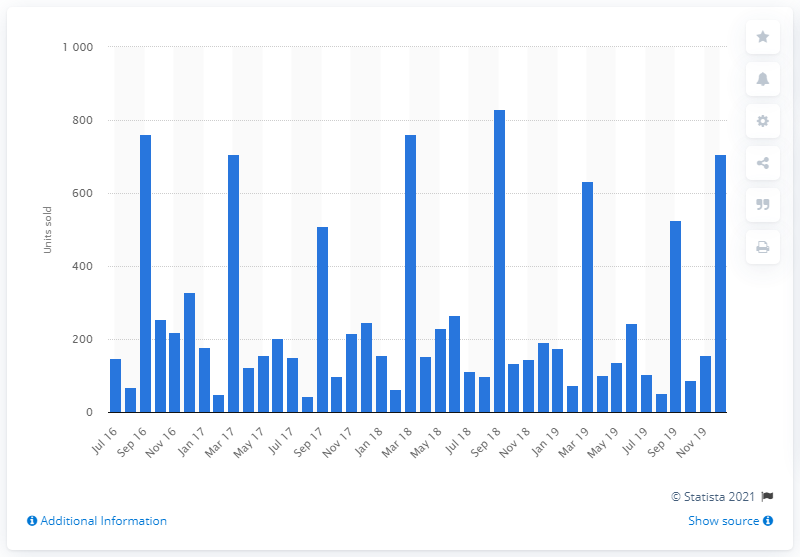Mention a couple of crucial points in this snapshot. Between July 2016 and December 2019, a total of 708 new Subaru cars were sold in the UK. 